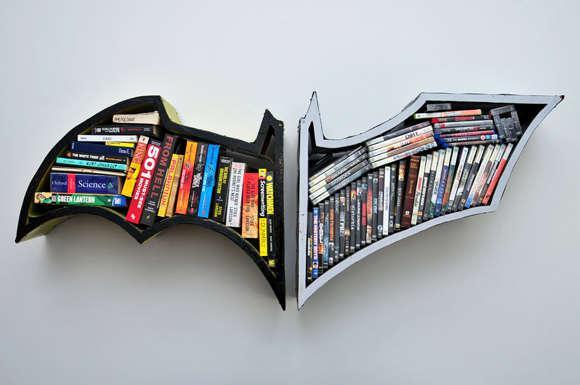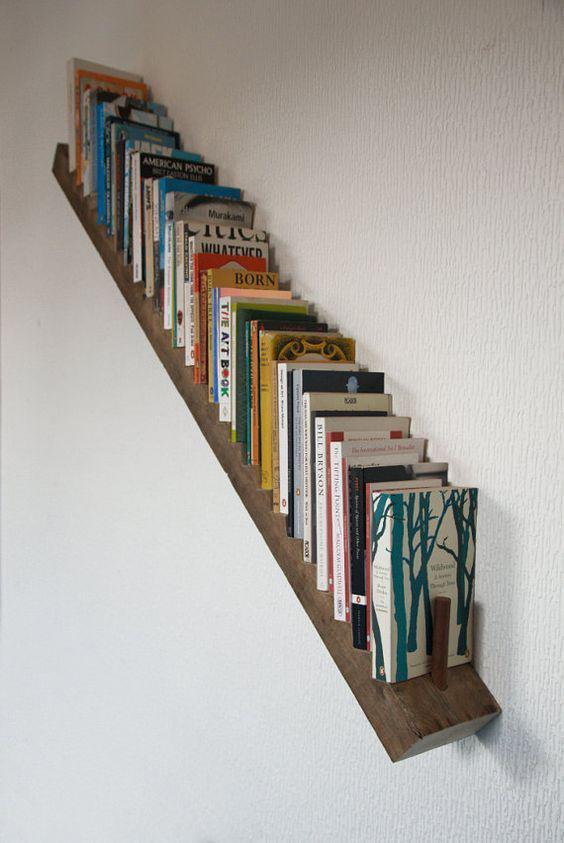The first image is the image on the left, the second image is the image on the right. Analyze the images presented: Is the assertion "In one image, a rectangular shelf unit has been created by attaching individual wooden boxes to a wall, leaving open space between them where the wall is visible." valid? Answer yes or no. No. The first image is the image on the left, the second image is the image on the right. For the images displayed, is the sentence "Books are hanging in traditional rectangular boxes on the wall in the image on the right." factually correct? Answer yes or no. No. 